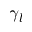Convert formula to latex. <formula><loc_0><loc_0><loc_500><loc_500>\gamma _ { l }</formula> 